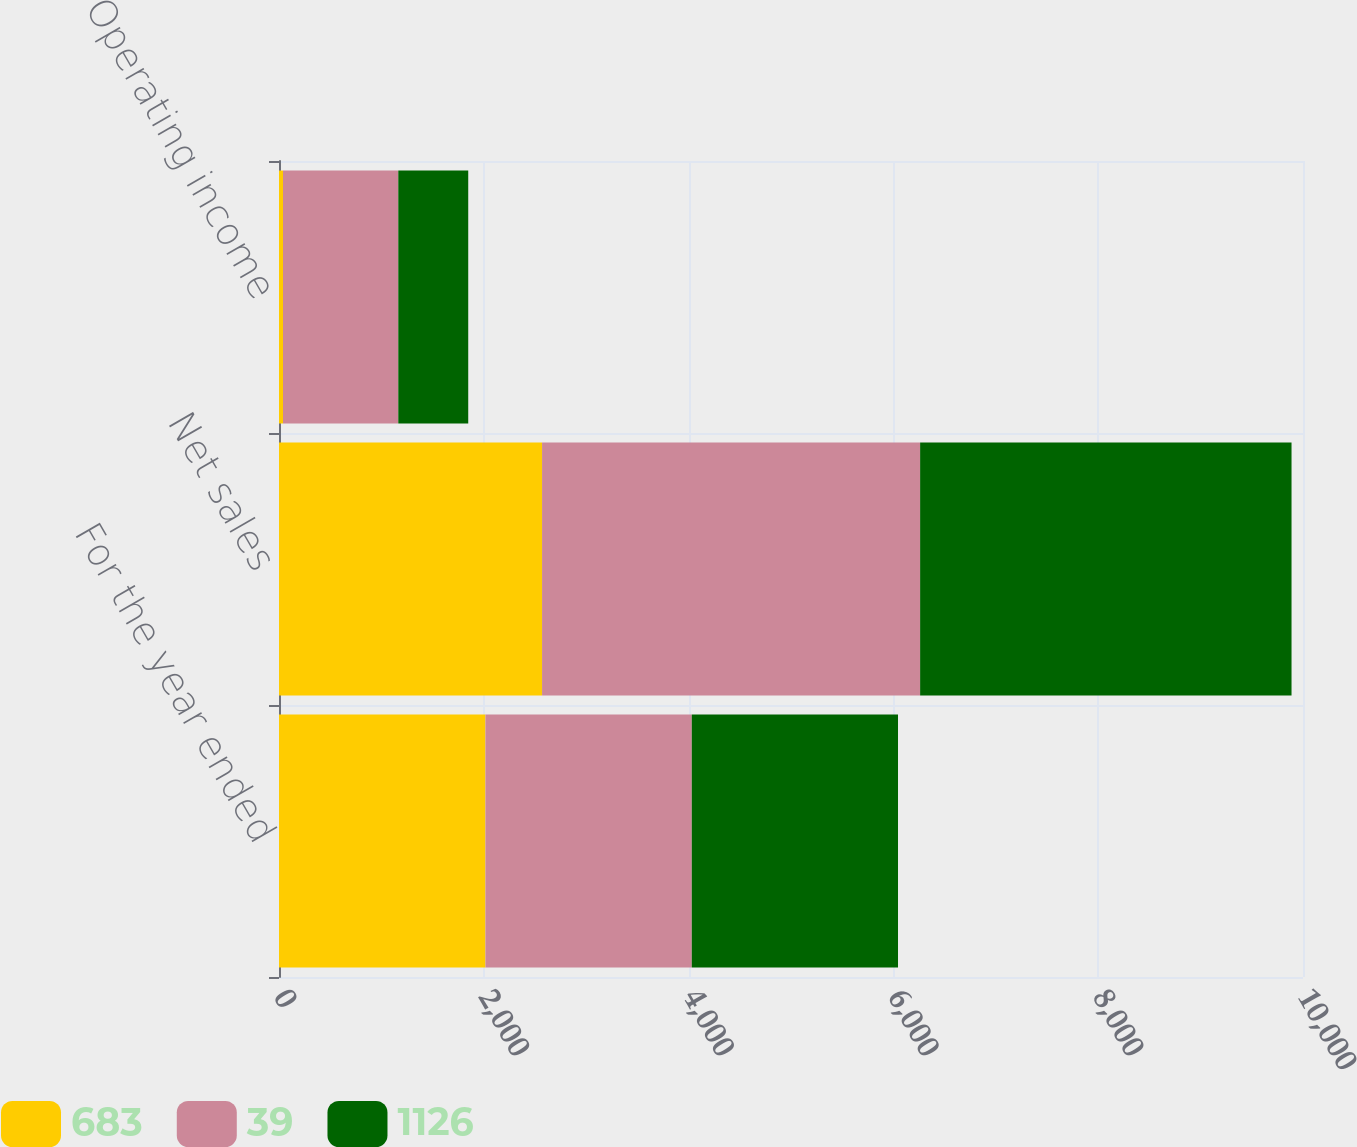<chart> <loc_0><loc_0><loc_500><loc_500><stacked_bar_chart><ecel><fcel>For the year ended<fcel>Net sales<fcel>Operating income<nl><fcel>683<fcel>2016<fcel>2569<fcel>39<nl><fcel>39<fcel>2015<fcel>3692<fcel>1126<nl><fcel>1126<fcel>2014<fcel>3627<fcel>683<nl></chart> 